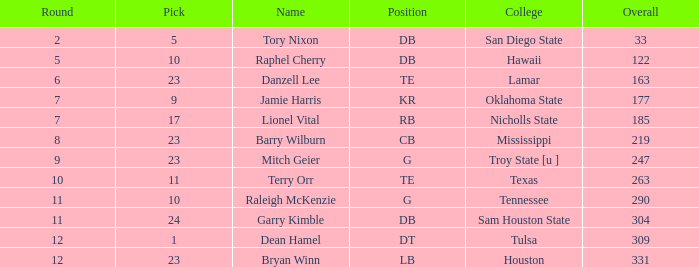How many Picks have an Overall smaller than 304, and a Position of g, and a Round smaller than 11? 1.0. 